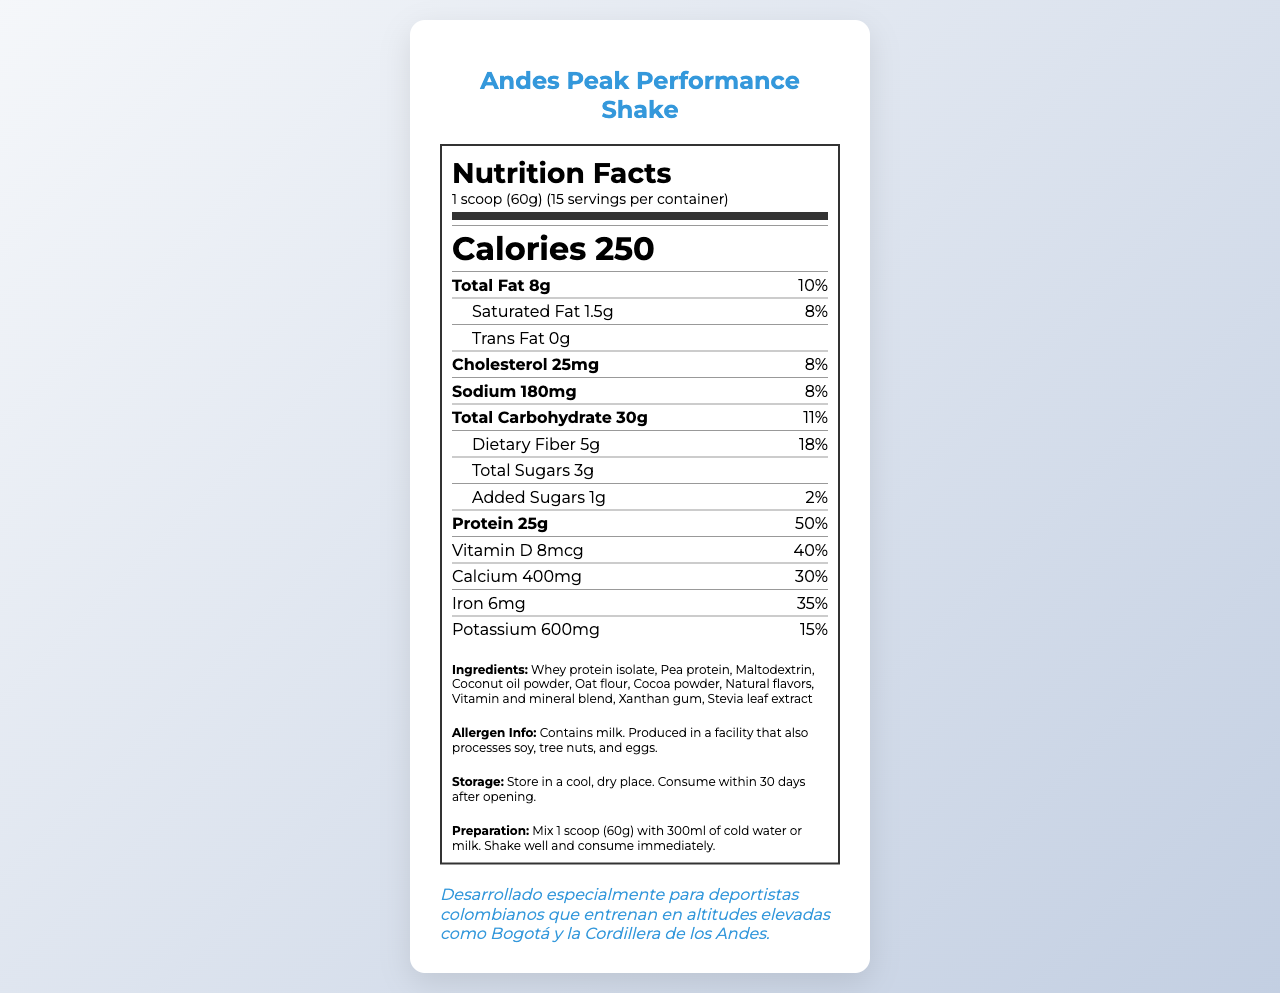what is the serving size of the Andes Peak Performance Shake? The serving size is specified in the serving information section of the document.
Answer: 1 scoop (60g) how many calories are in one serving of the shake? The calorie content is clearly listed as "Calories 250" in the nutrient row.
Answer: 250 what is the total amount of protein per serving? The protein amount is specified as 25g in the nutrient row.
Answer: 25g what are the main ingredients of the shake? The ingredients list is explicitly mentioned under the ingredients section.
Answer: Whey protein isolate, Pea protein, Maltodextrin, Coconut oil powder, Oat flour, Cocoa powder, Natural flavors, Vitamin and mineral blend, Xanthan gum, Stevia leaf extract. how much Vitamin C does the shake contain per serving? The amount of Vitamin C is specified as 90mg under the nutrient row for vitamins.
Answer: 90mg what percentage of the daily value does the shake provide for iron? The daily value for iron is listed as 35% in the nutrient row for minerals.
Answer: 35% what is the preparation instruction for the shake? The preparation instructions are clearly detailed in the preparation section.
Answer: Mix 1 scoop (60g) with 300ml of cold water or milk. Shake well and consume immediately. what is the total carbohydrate content per serving, including the dietary fiber? The total carbohydrate amount is 30g, and the dietary fiber is an additional 5g, as specified in the carbohydrate section.
Answer: Total Carbohydrate 30g, Dietary Fiber 5g how many servings are there per container? The number of servings per container is listed in the serving information section.
Answer: 15 does the shake contain any added sugars? The document shows that the shake contains 1g of added sugars.
Answer: Yes which of these is NOT an ingredient in the shake? A. Cocoa powder B. Maltodextrin C. High fructose corn syrup D. Stevia leaf extract High fructose corn syrup is not listed as one of the ingredients.
Answer: C how much beta-alanine is included in the shake? A. 1g B. 1.5g C. 2g D. 3g The document specifies that beta-alanine content is 1.5g.
Answer: B does the shake contain any trans fat? The document explicitly mentions "Trans Fat 0g."
Answer: No what special note is included for Colombian athletes? There is a special note at the bottom of the document for Colombian athletes training at high altitudes.
Answer: Desarrollado especialmente para deportistas colombianos que entrenan en altitudes elevadas como Bogotá y la Cordillera de los Andes. can the allergen information be determined from the document? The document states that it contains milk and is produced in a facility that processes soy, tree nuts, and eggs.
Answer: Yes how should the shake be stored? The storage instructions are clearly provided in the relevant section.
Answer: Store in a cool, dry place. Consume within 30 days after opening. what is the document mainly about? The document is structured to provide comprehensive information about the nutrition facts, usage, and benefits of the Andes Peak Performance Shake.
Answer: The Andes Peak Performance Shake and its nutritional content, preparation instructions, storage guidelines, ingredient list, and special notes for athletes. how many calories come from fat? The document does not provide specific details about the calories obtained from fat.
Answer: Not enough information 